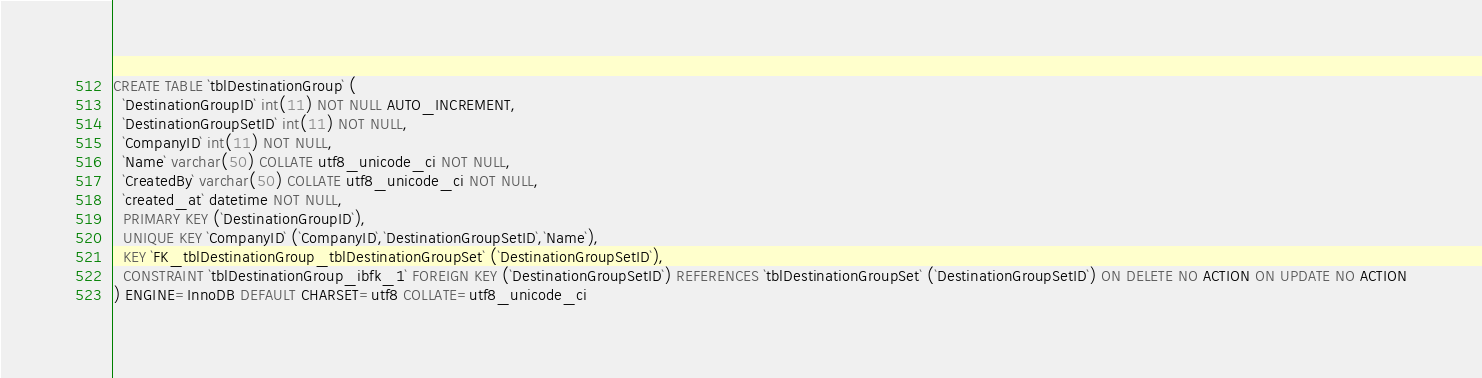<code> <loc_0><loc_0><loc_500><loc_500><_SQL_>CREATE TABLE `tblDestinationGroup` (
  `DestinationGroupID` int(11) NOT NULL AUTO_INCREMENT,
  `DestinationGroupSetID` int(11) NOT NULL,
  `CompanyID` int(11) NOT NULL,
  `Name` varchar(50) COLLATE utf8_unicode_ci NOT NULL,
  `CreatedBy` varchar(50) COLLATE utf8_unicode_ci NOT NULL,
  `created_at` datetime NOT NULL,
  PRIMARY KEY (`DestinationGroupID`),
  UNIQUE KEY `CompanyID` (`CompanyID`,`DestinationGroupSetID`,`Name`),
  KEY `FK_tblDestinationGroup_tblDestinationGroupSet` (`DestinationGroupSetID`),
  CONSTRAINT `tblDestinationGroup_ibfk_1` FOREIGN KEY (`DestinationGroupSetID`) REFERENCES `tblDestinationGroupSet` (`DestinationGroupSetID`) ON DELETE NO ACTION ON UPDATE NO ACTION
) ENGINE=InnoDB DEFAULT CHARSET=utf8 COLLATE=utf8_unicode_ci</code> 